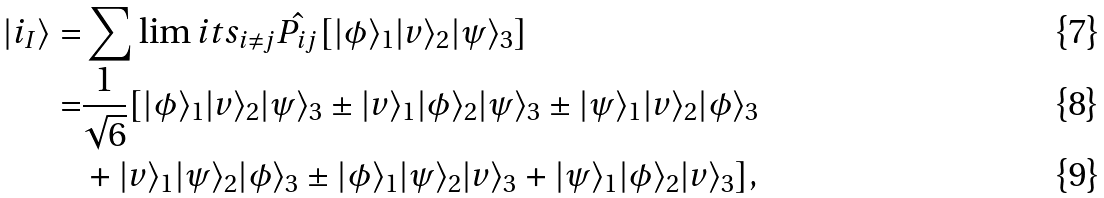<formula> <loc_0><loc_0><loc_500><loc_500>| i _ { I } \rangle = & \sum \lim i t s _ { i \neq j } \hat { P _ { i j } } [ | \phi \rangle _ { 1 } | v \rangle _ { 2 } | \psi \rangle _ { 3 } ] \\ = & \frac { 1 } { \sqrt { 6 } } [ | \phi \rangle _ { 1 } | v \rangle _ { 2 } | \psi \rangle _ { 3 } \pm | v \rangle _ { 1 } | \phi \rangle _ { 2 } | \psi \rangle _ { 3 } \pm | \psi \rangle _ { 1 } | v \rangle _ { 2 } | \phi \rangle _ { 3 } \\ & + | v \rangle _ { 1 } | \psi \rangle _ { 2 } | \phi \rangle _ { 3 } \pm | \phi \rangle _ { 1 } | \psi \rangle _ { 2 } | v \rangle _ { 3 } + | \psi \rangle _ { 1 } | \phi \rangle _ { 2 } | v \rangle _ { 3 } ] ,</formula> 